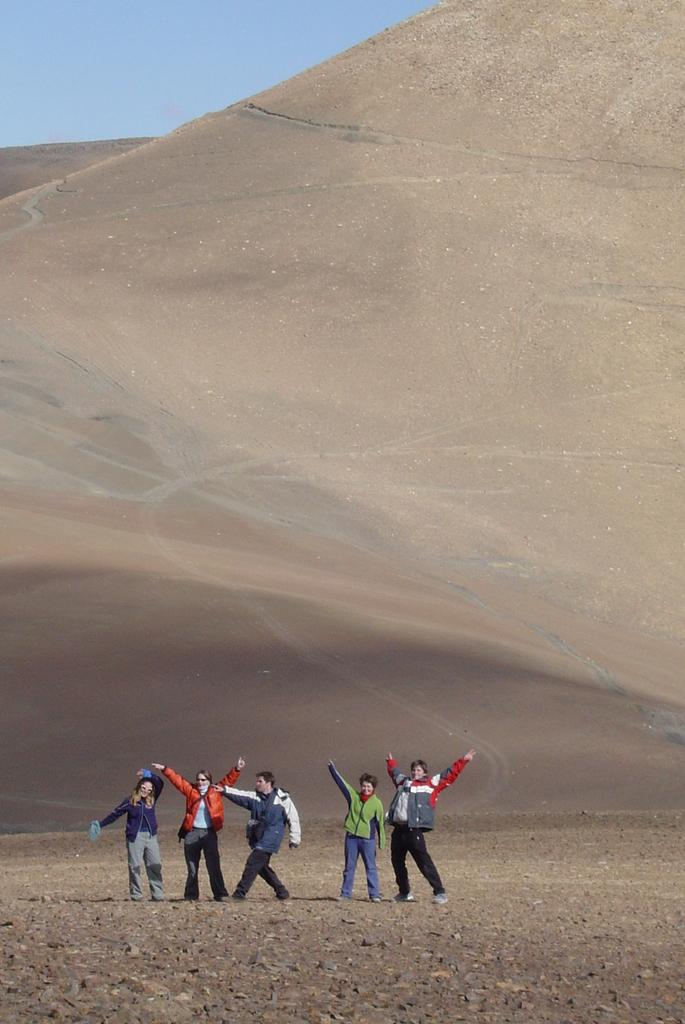How many persons are in the image? There are persons in the image. What type of clothing are the persons wearing? The persons are wearing jerkins. Where are the persons standing in the image? The persons are standing on the land. What can be seen in the background of the image? There is a hill in the background of the image. What is visible above the hill in the image? The sky is visible above the hill. What type of lamp is hanging from the arm of the person on the left in the image? There is no lamp or arm visible in the image; the persons are wearing jerkins and standing on the land. 